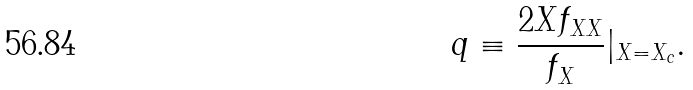<formula> <loc_0><loc_0><loc_500><loc_500>q \equiv \frac { 2 X f _ { X X } } { f _ { X } } | _ { X = X _ { c } } .</formula> 